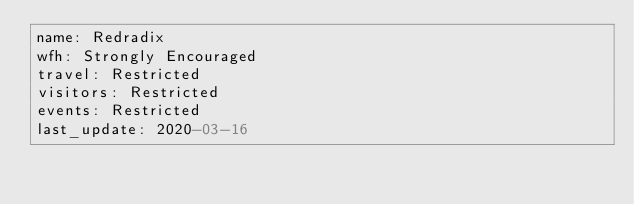Convert code to text. <code><loc_0><loc_0><loc_500><loc_500><_YAML_>name: Redradix
wfh: Strongly Encouraged
travel: Restricted
visitors: Restricted
events: Restricted
last_update: 2020-03-16
</code> 